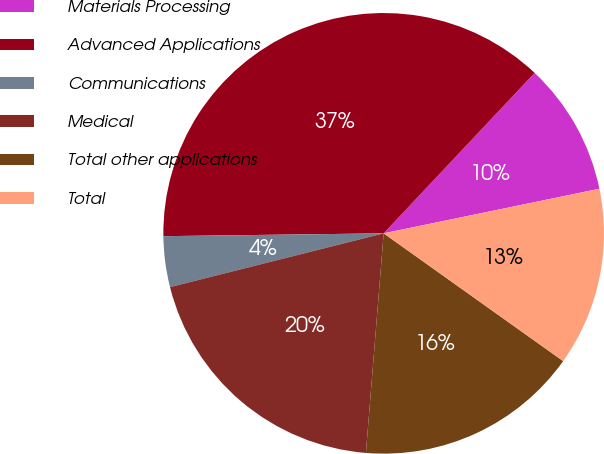Convert chart to OTSL. <chart><loc_0><loc_0><loc_500><loc_500><pie_chart><fcel>Materials Processing<fcel>Advanced Applications<fcel>Communications<fcel>Medical<fcel>Total other applications<fcel>Total<nl><fcel>9.74%<fcel>37.22%<fcel>3.72%<fcel>19.79%<fcel>16.44%<fcel>13.09%<nl></chart> 